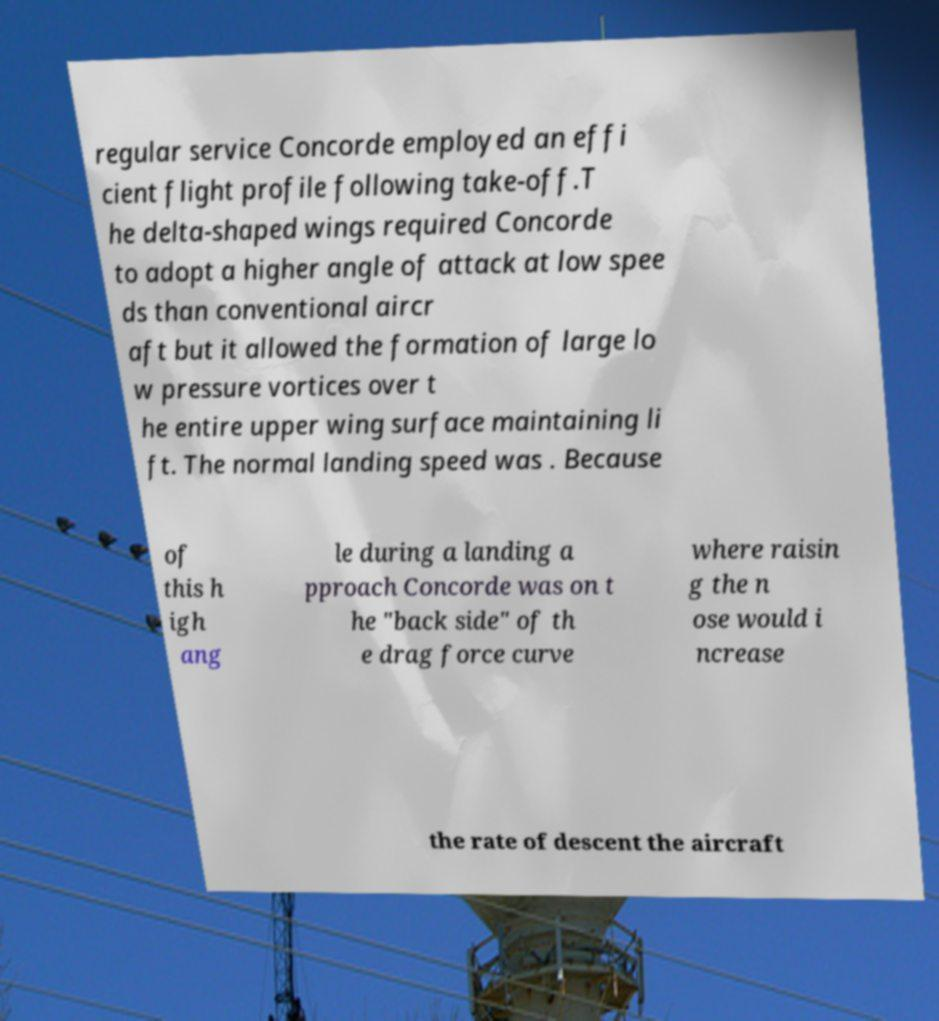Could you assist in decoding the text presented in this image and type it out clearly? regular service Concorde employed an effi cient flight profile following take-off.T he delta-shaped wings required Concorde to adopt a higher angle of attack at low spee ds than conventional aircr aft but it allowed the formation of large lo w pressure vortices over t he entire upper wing surface maintaining li ft. The normal landing speed was . Because of this h igh ang le during a landing a pproach Concorde was on t he "back side" of th e drag force curve where raisin g the n ose would i ncrease the rate of descent the aircraft 